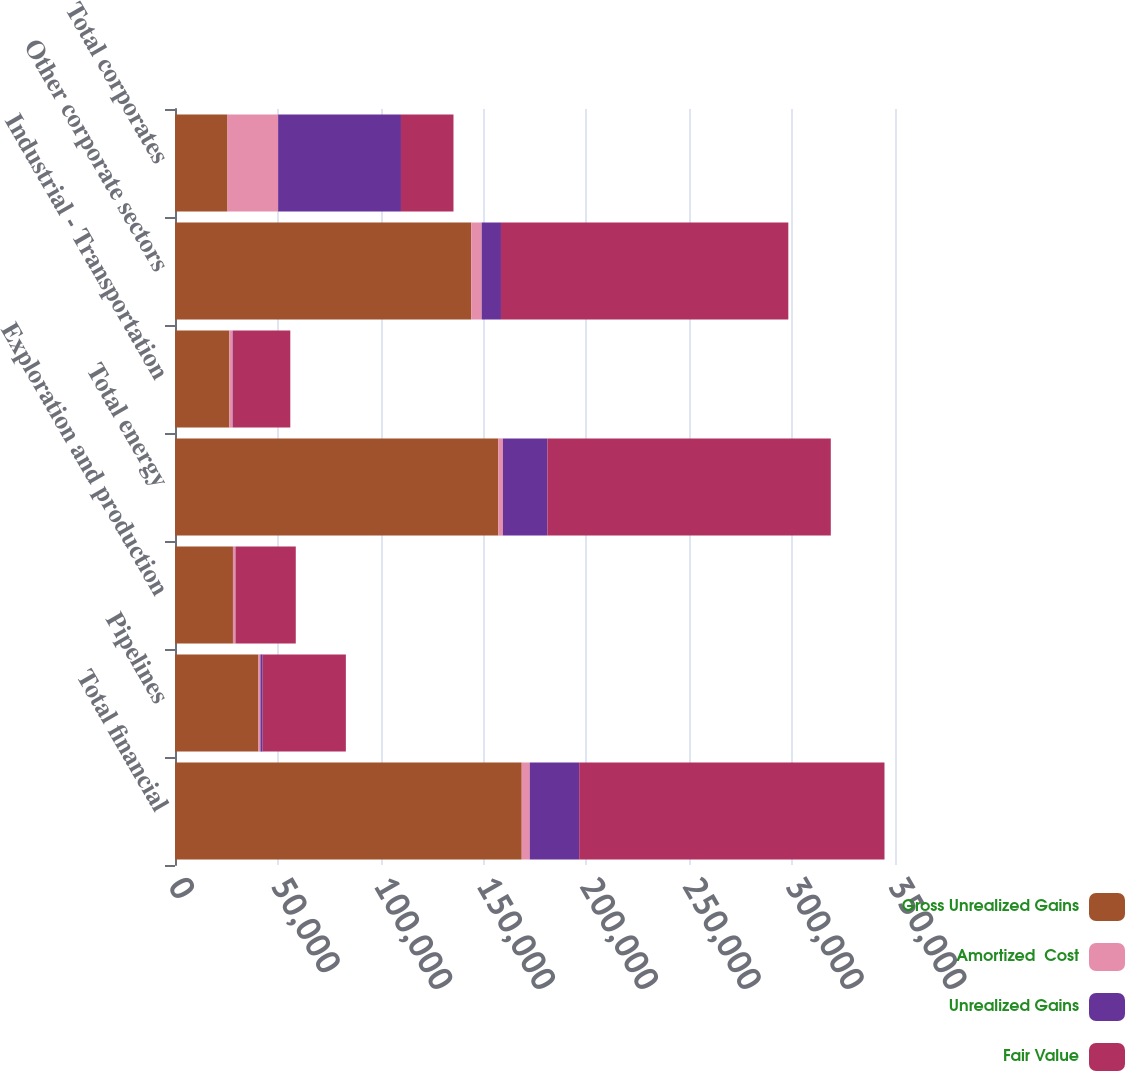Convert chart to OTSL. <chart><loc_0><loc_0><loc_500><loc_500><stacked_bar_chart><ecel><fcel>Total financial<fcel>Pipelines<fcel>Exploration and production<fcel>Total energy<fcel>Industrial - Transportation<fcel>Other corporate sectors<fcel>Total corporates<nl><fcel>Gross Unrealized Gains<fcel>168549<fcel>40590<fcel>28174<fcel>157192<fcel>26443<fcel>143995<fcel>25525.5<nl><fcel>Amortized  Cost<fcel>3896<fcel>937<fcel>1180<fcel>2204<fcel>1581<fcel>5076<fcel>24608<nl><fcel>Unrealized Gains<fcel>24038<fcel>1092<fcel>85<fcel>21629<fcel>162<fcel>9387<fcel>59714<nl><fcel>Fair Value<fcel>148407<fcel>40435<fcel>29269<fcel>137767<fcel>27862<fcel>139684<fcel>25525.5<nl></chart> 